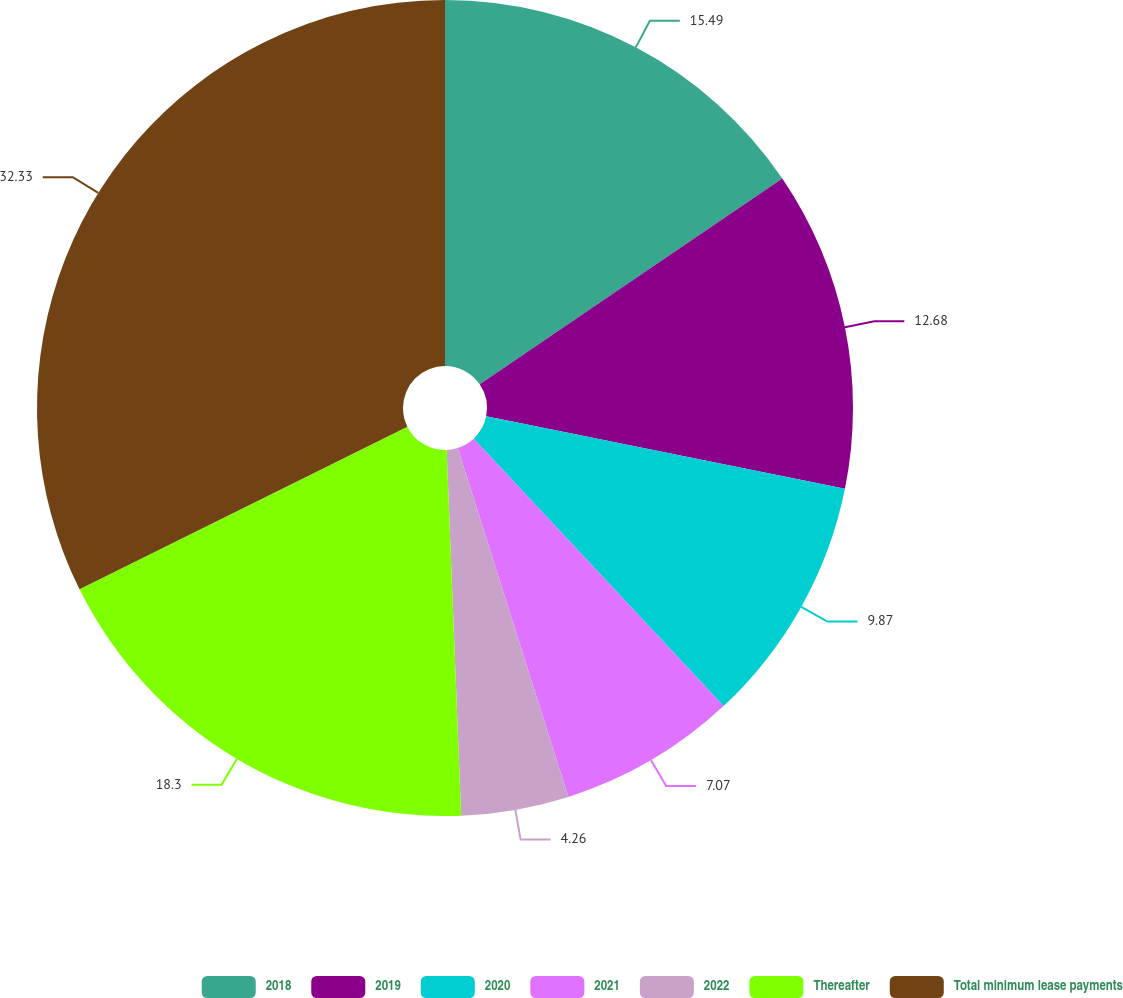Convert chart to OTSL. <chart><loc_0><loc_0><loc_500><loc_500><pie_chart><fcel>2018<fcel>2019<fcel>2020<fcel>2021<fcel>2022<fcel>Thereafter<fcel>Total minimum lease payments<nl><fcel>15.49%<fcel>12.68%<fcel>9.87%<fcel>7.07%<fcel>4.26%<fcel>18.3%<fcel>32.33%<nl></chart> 